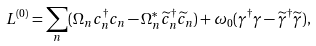Convert formula to latex. <formula><loc_0><loc_0><loc_500><loc_500>L ^ { ( 0 ) } = \sum _ { n } ( \Omega _ { n } c ^ { \dag } _ { n } c _ { n } - \Omega ^ { * } _ { n } \widetilde { c } ^ { \dag } _ { n } \widetilde { c } _ { n } ) + \omega _ { 0 } ( \gamma ^ { \dag } \gamma - \widetilde { \gamma } ^ { \dag } \widetilde { \gamma } ) ,</formula> 